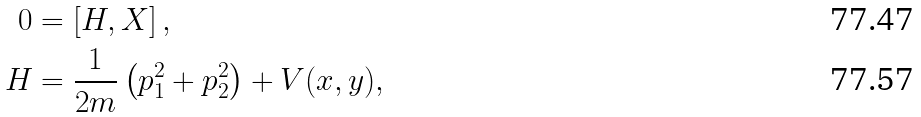<formula> <loc_0><loc_0><loc_500><loc_500>0 & = \left [ H , X \right ] , \\ H & = \frac { 1 } { 2 m } \left ( p _ { 1 } ^ { 2 } + p _ { 2 } ^ { 2 } \right ) + V ( x , y ) ,</formula> 